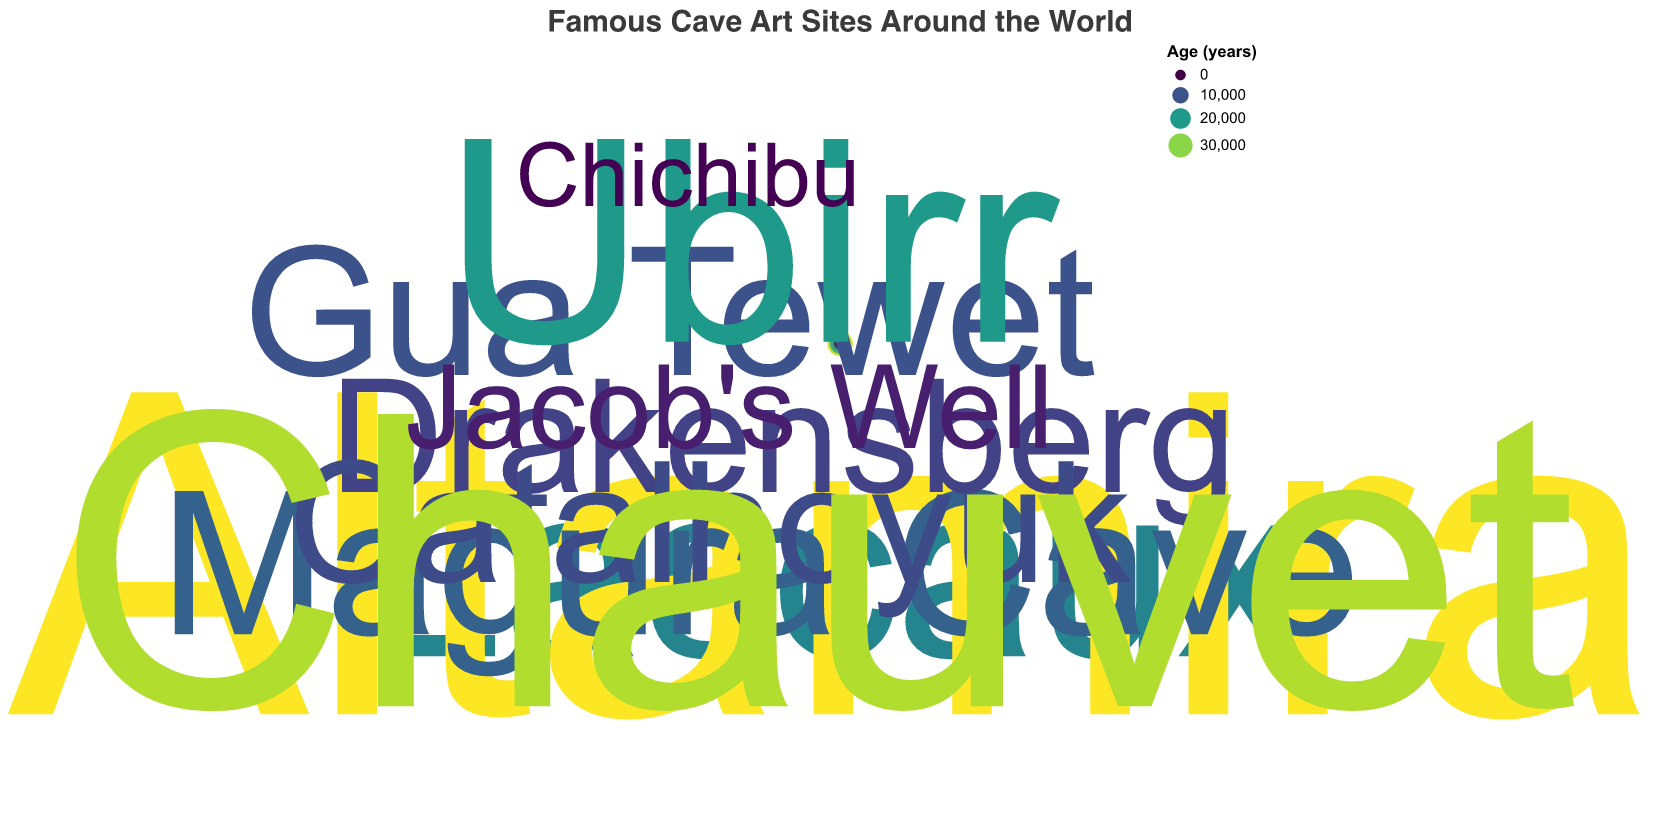How many cave art sites are shown in the figure? Count the number of data points (scatter points) in the chart. There are a total of 10 data points, corresponding to the 10 cave art sites listed in the dataset.
Answer: 10 Which cave art site has the youngest age? Identify the data point with the smallest "age" value in the chart. "Chichibu" has the smallest age of 1300 years.
Answer: Chichibu What is the average age of the cave art sites shown? Sum the ages of all cave art sites and divide by the number of sites: (17000 + 36000 + 12000 + 8000 + 10000 + 9000 + 32000 + 4000 + 20000 + 1300)/10 = 14930.
Answer: 14930 Which region (latitude) has the highest concentration of cave art sites? Observe the density of data points across different latitudes. Northern Hemisphere, particularly Europe.
Answer: Northern Hemisphere Which artist was inspired by the oldest cave art? Identify the data point with the largest "age" value and find the corresponding "inspired_modern_artist". "Pablo Picasso" was inspired by "Altamira," which is 36000 years old.
Answer: Pablo Picasso What is the range of longitudes covered by the cave art sites? Observe the theta (longitude) values in the chart; the range is from approximately -180 to 137.25.
Answer: -180 to 137.25 How is the color of the data points related to the age of the cave art sites? Inspect the color legend corresponding to "age." Older sites have a different color, moving from lighter to darker shades as the age increases.
Answer: Age is shown by color, with older sites in darker shades Are there more cave art sites in the Northern or Southern Hemisphere? Count data points with positive and negative latitude values. There are 7 in the Northern Hemisphere and 3 in the Southern Hemisphere.
Answer: Northern Hemisphere Which cave art site inspired Jean Dubuffet, and what is its age? Look for the data point labeled "Lascaux," which is associated with Jean Dubuffet. The "age" field for Lascaux is 17000 years.
Answer: Lascaux, 17000 years What longitude is associated with the site that inspired Albert Namatjira? Find the data point related to "Ubirr," inspired by Albert Namatjira. The "longitude" for Ubirr is 133.87.
Answer: 133.87 